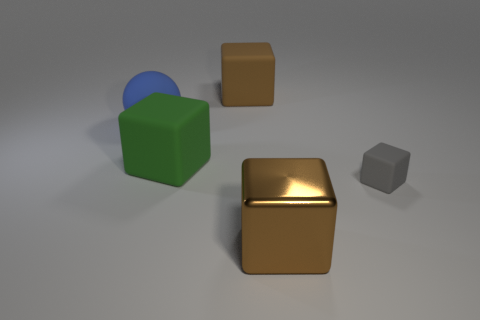Subtract 1 cubes. How many cubes are left? 3 Add 3 shiny things. How many objects exist? 8 Subtract all cubes. How many objects are left? 1 Add 4 green blocks. How many green blocks exist? 5 Subtract 0 purple balls. How many objects are left? 5 Subtract all large blue rubber spheres. Subtract all large blue rubber balls. How many objects are left? 3 Add 5 brown matte objects. How many brown matte objects are left? 6 